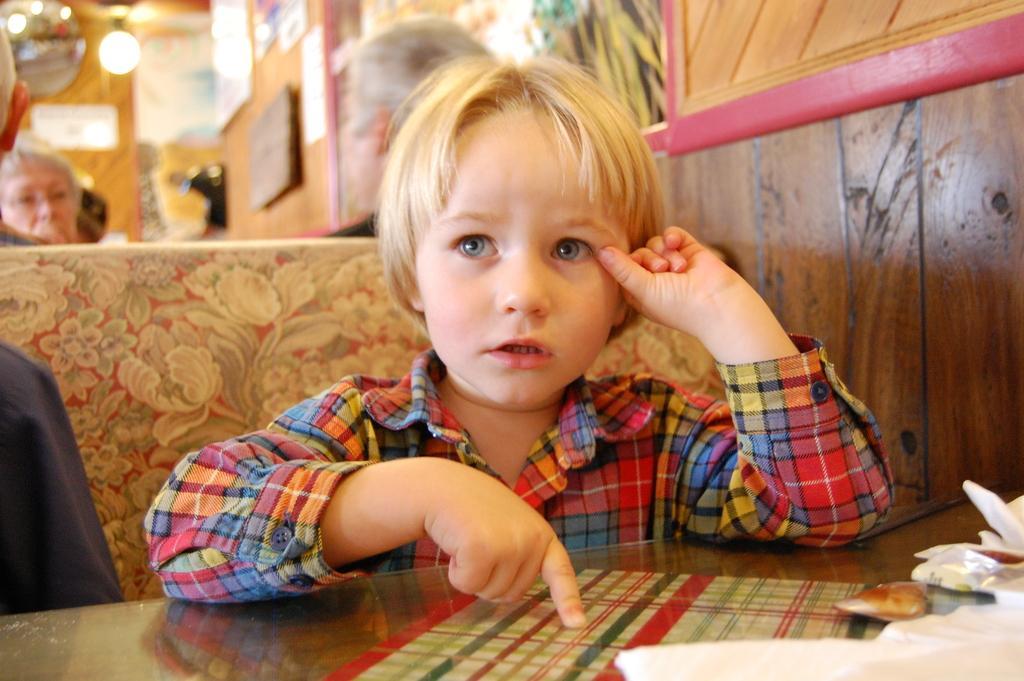Please provide a concise description of this image. A kid is sitting on the chair at the table behind him there are people sitting on the chair and light. 